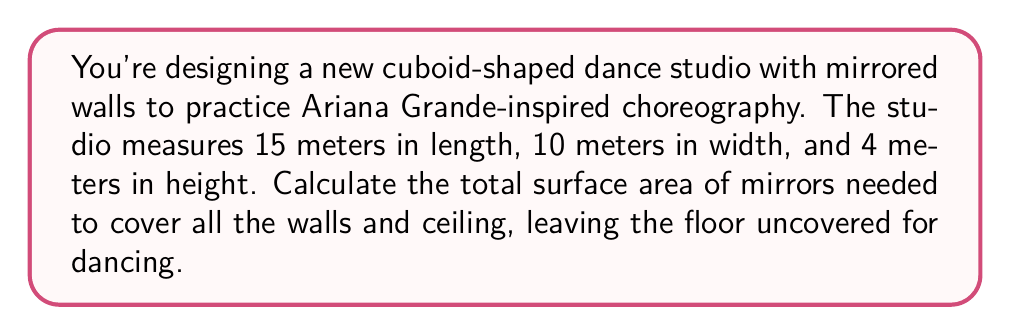Can you answer this question? Let's approach this step-by-step:

1) First, recall the formula for the surface area of a cuboid:
   $$ SA = 2(lw + lh + wh) $$
   Where $l$ is length, $w$ is width, and $h$ is height.

2) We're covering all surfaces except the floor, so we need to subtract one $lw$ term:
   $$ SA_{mirrors} = 2lw + 2lh + 2wh $$

3) Now, let's substitute our values:
   $l = 15$ m, $w = 10$ m, $h = 4$ m

4) Calculating each term:
   $2lw = 2(15 \cdot 10) = 300$ m²
   $2lh = 2(15 \cdot 4) = 120$ m²
   $2wh = 2(10 \cdot 4) = 80$ m²

5) Sum up all terms:
   $$ SA_{mirrors} = 300 + 120 + 80 = 500 \text{ m²} $$

Therefore, you need 500 square meters of mirrors to cover the walls and ceiling of your Ariana-inspired dance studio.
Answer: 500 m² 